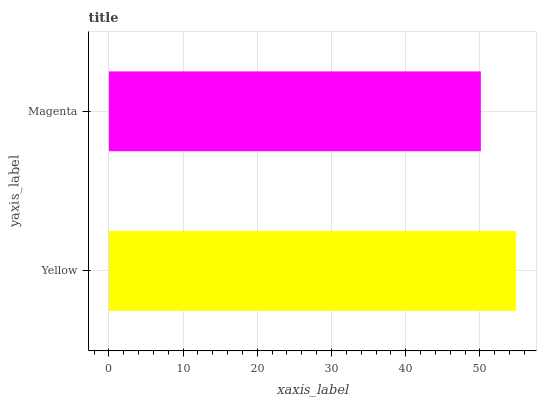Is Magenta the minimum?
Answer yes or no. Yes. Is Yellow the maximum?
Answer yes or no. Yes. Is Magenta the maximum?
Answer yes or no. No. Is Yellow greater than Magenta?
Answer yes or no. Yes. Is Magenta less than Yellow?
Answer yes or no. Yes. Is Magenta greater than Yellow?
Answer yes or no. No. Is Yellow less than Magenta?
Answer yes or no. No. Is Yellow the high median?
Answer yes or no. Yes. Is Magenta the low median?
Answer yes or no. Yes. Is Magenta the high median?
Answer yes or no. No. Is Yellow the low median?
Answer yes or no. No. 